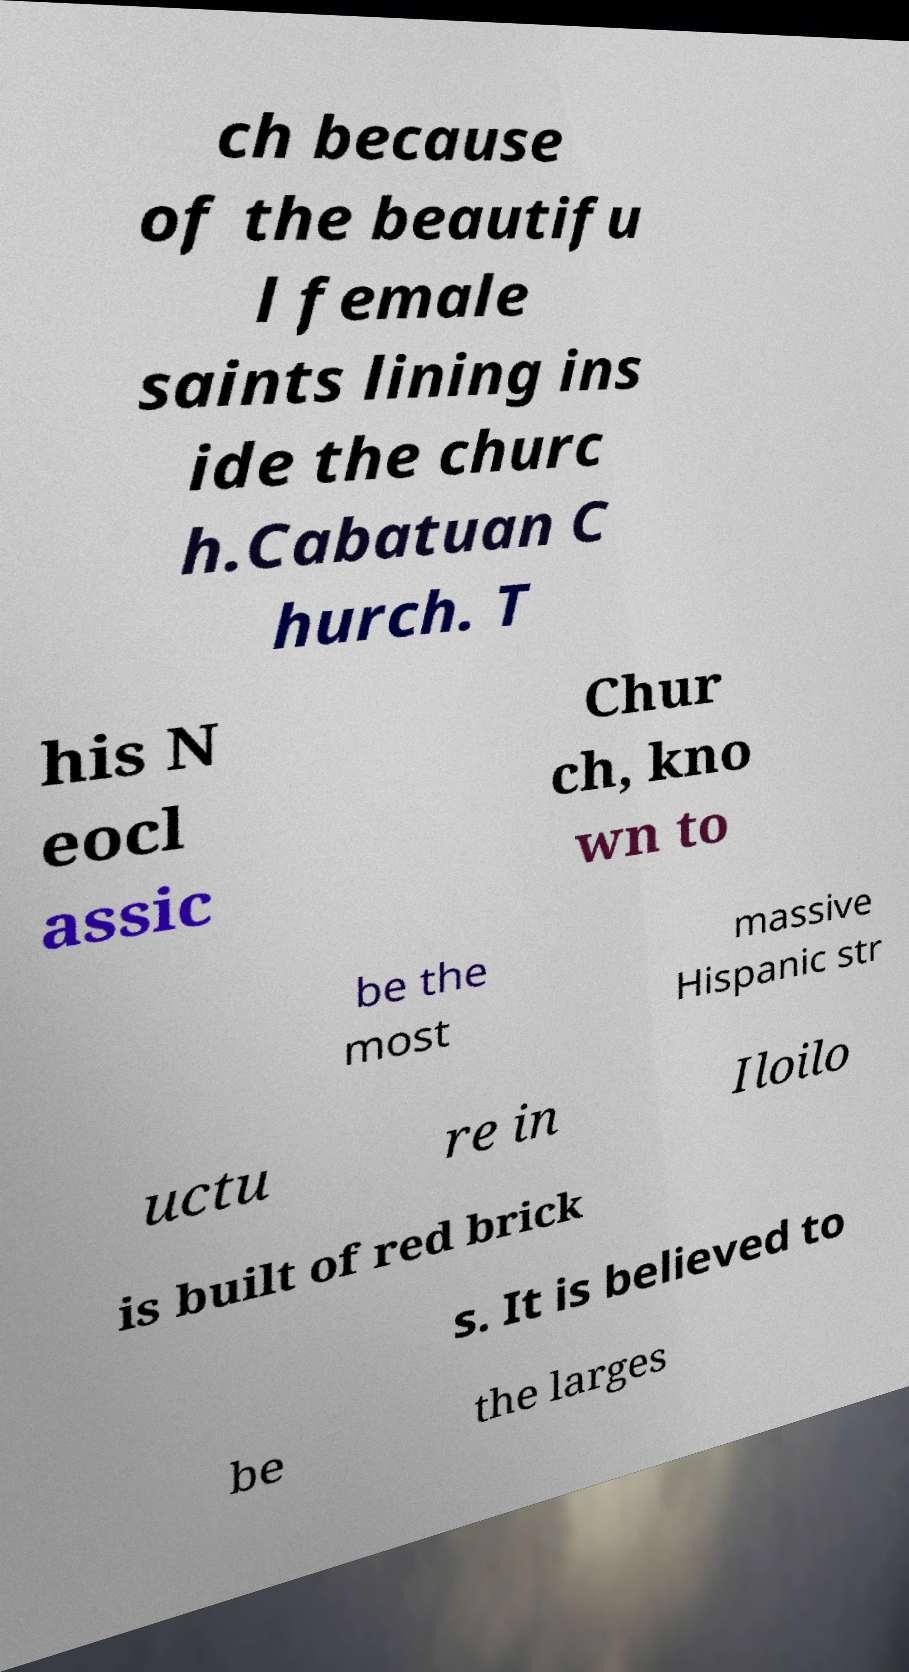Could you assist in decoding the text presented in this image and type it out clearly? ch because of the beautifu l female saints lining ins ide the churc h.Cabatuan C hurch. T his N eocl assic Chur ch, kno wn to be the most massive Hispanic str uctu re in Iloilo is built of red brick s. It is believed to be the larges 